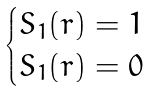Convert formula to latex. <formula><loc_0><loc_0><loc_500><loc_500>\begin{cases} S _ { 1 } ( r ) = 1 & \\ S _ { 1 } ( r ) = 0 & \end{cases}</formula> 